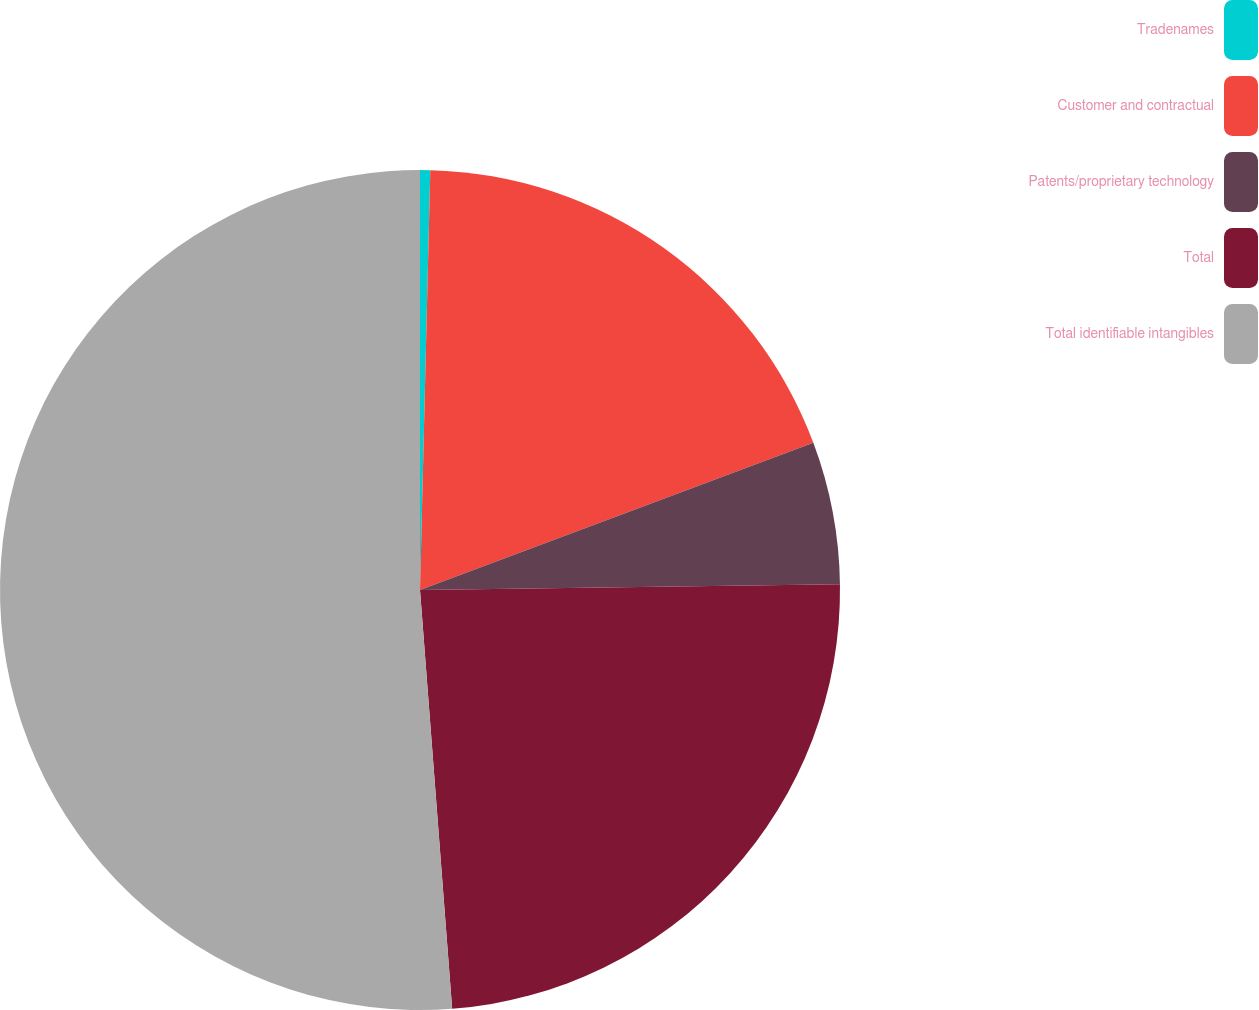<chart> <loc_0><loc_0><loc_500><loc_500><pie_chart><fcel>Tradenames<fcel>Customer and contractual<fcel>Patents/proprietary technology<fcel>Total<fcel>Total identifiable intangibles<nl><fcel>0.39%<fcel>18.91%<fcel>5.48%<fcel>24.0%<fcel>51.22%<nl></chart> 